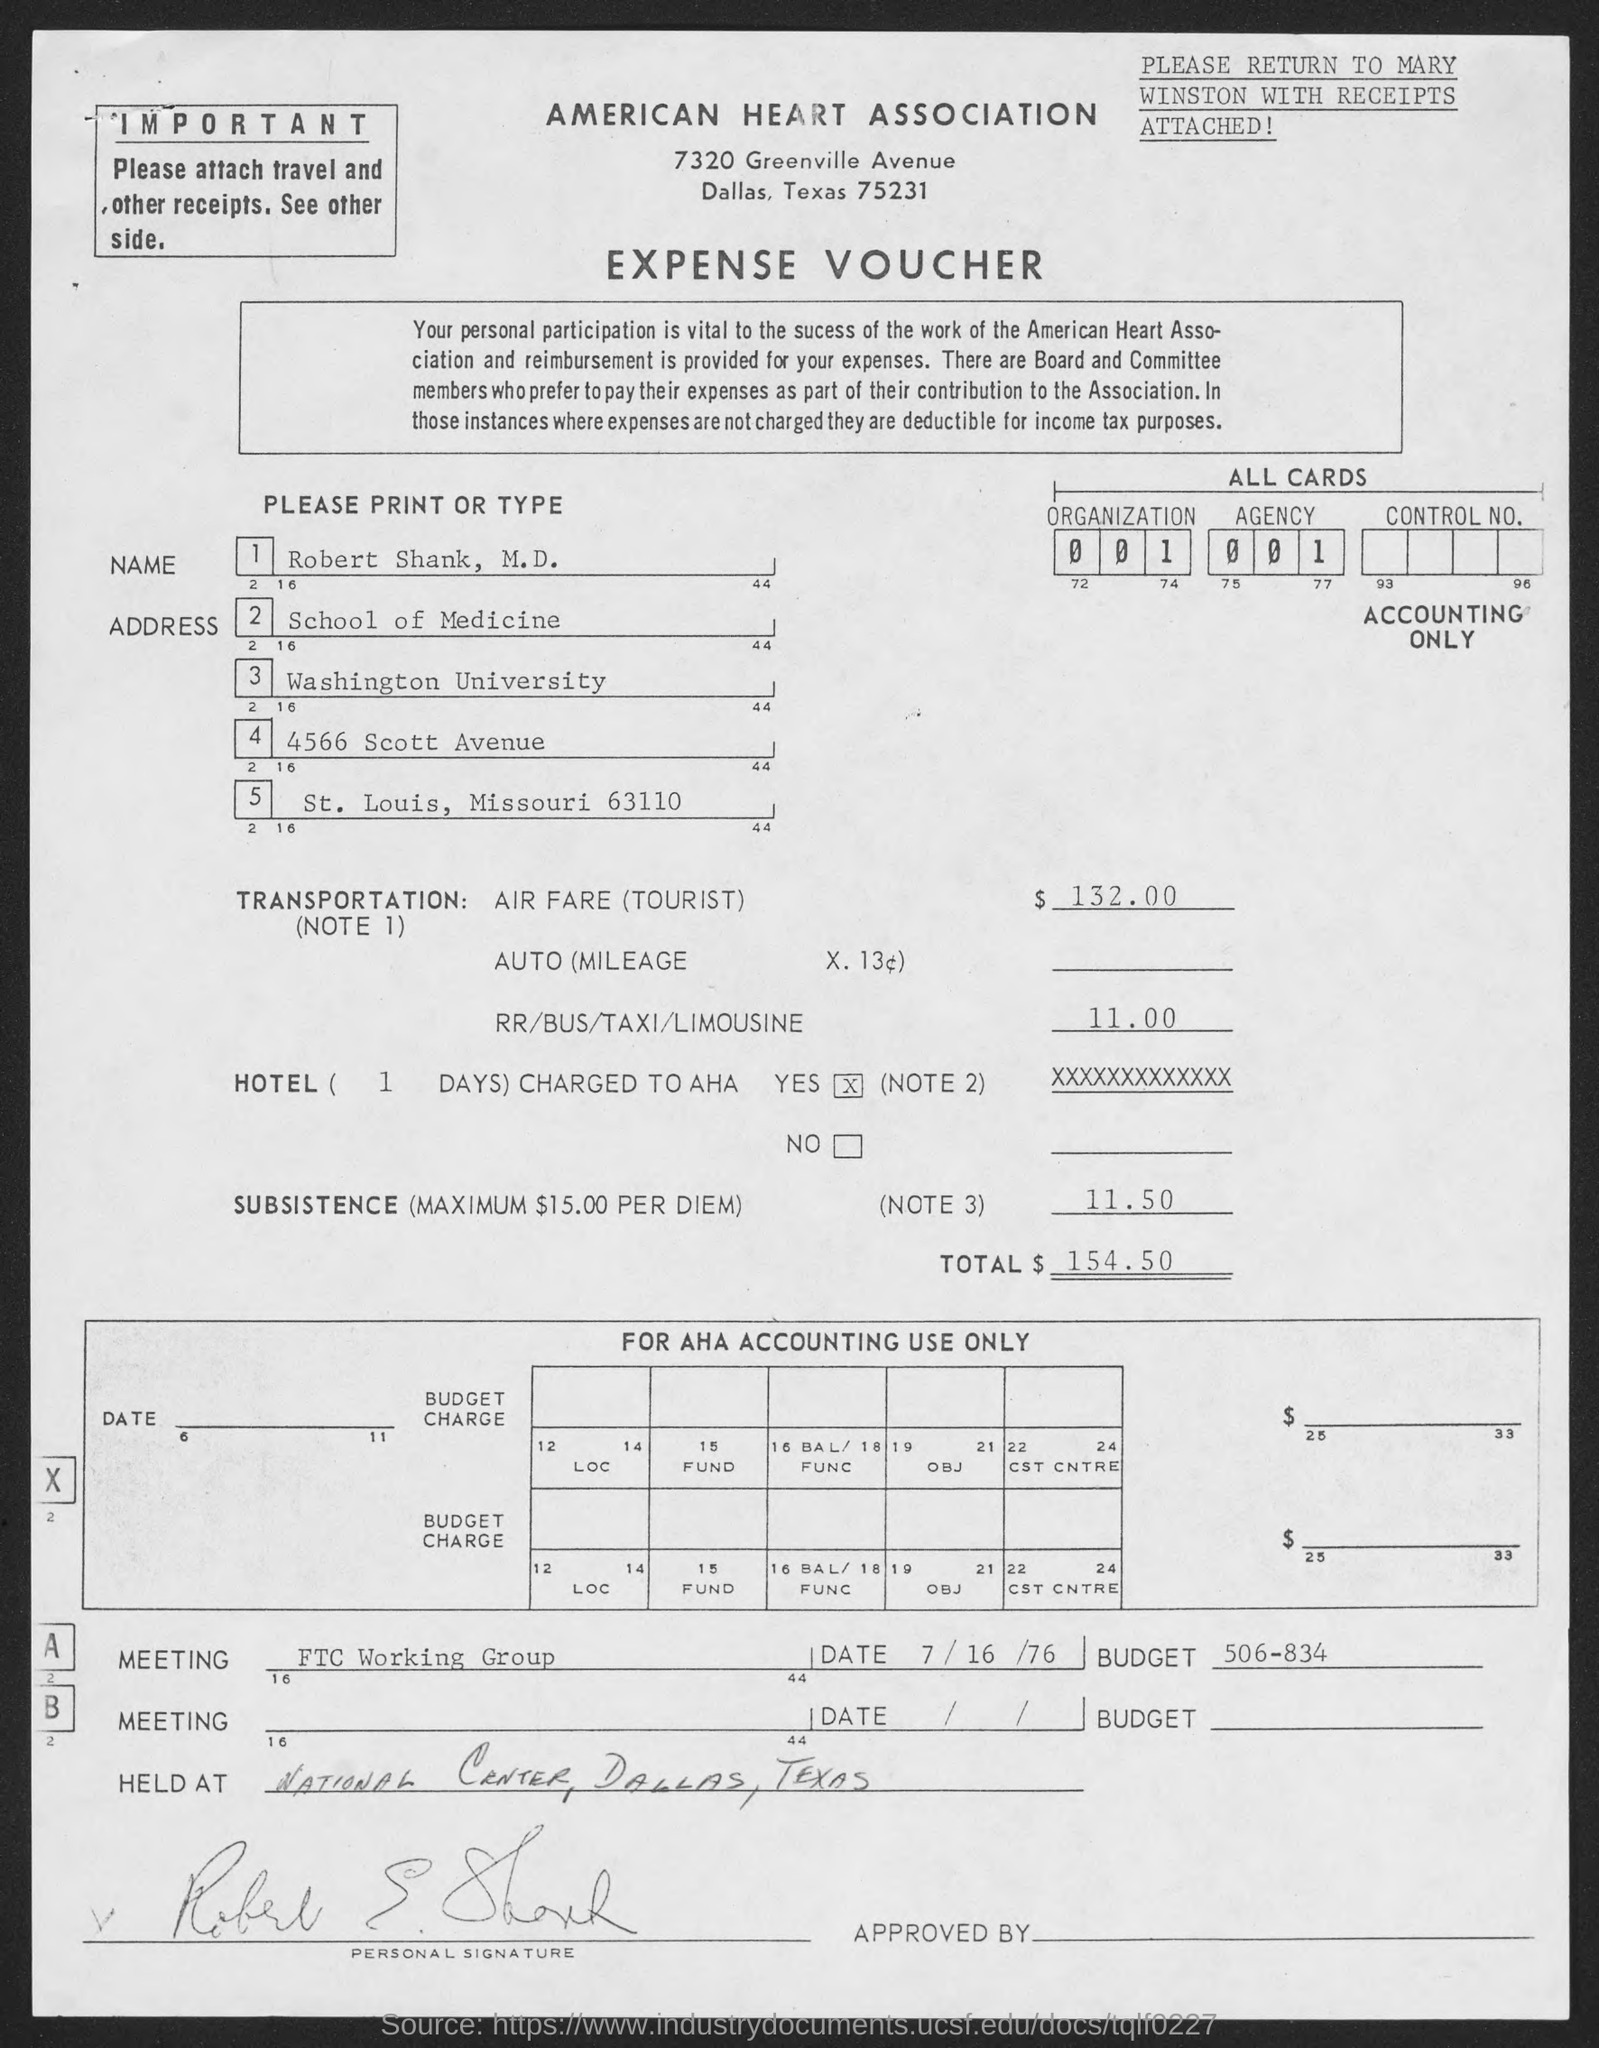What is the name in the expense voucher ?
Your answer should be compact. Robert Shank, M.D. To which university does robert shank, m.d. belong.?
Keep it short and to the point. Washington university. What is the total amount of expense?
Offer a very short reply. $154.50. 